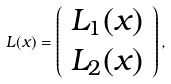<formula> <loc_0><loc_0><loc_500><loc_500>L ( x ) = \left ( \begin{array} { c } L _ { 1 } ( x ) \\ L _ { 2 } ( x ) \\ \end{array} \right ) ,</formula> 